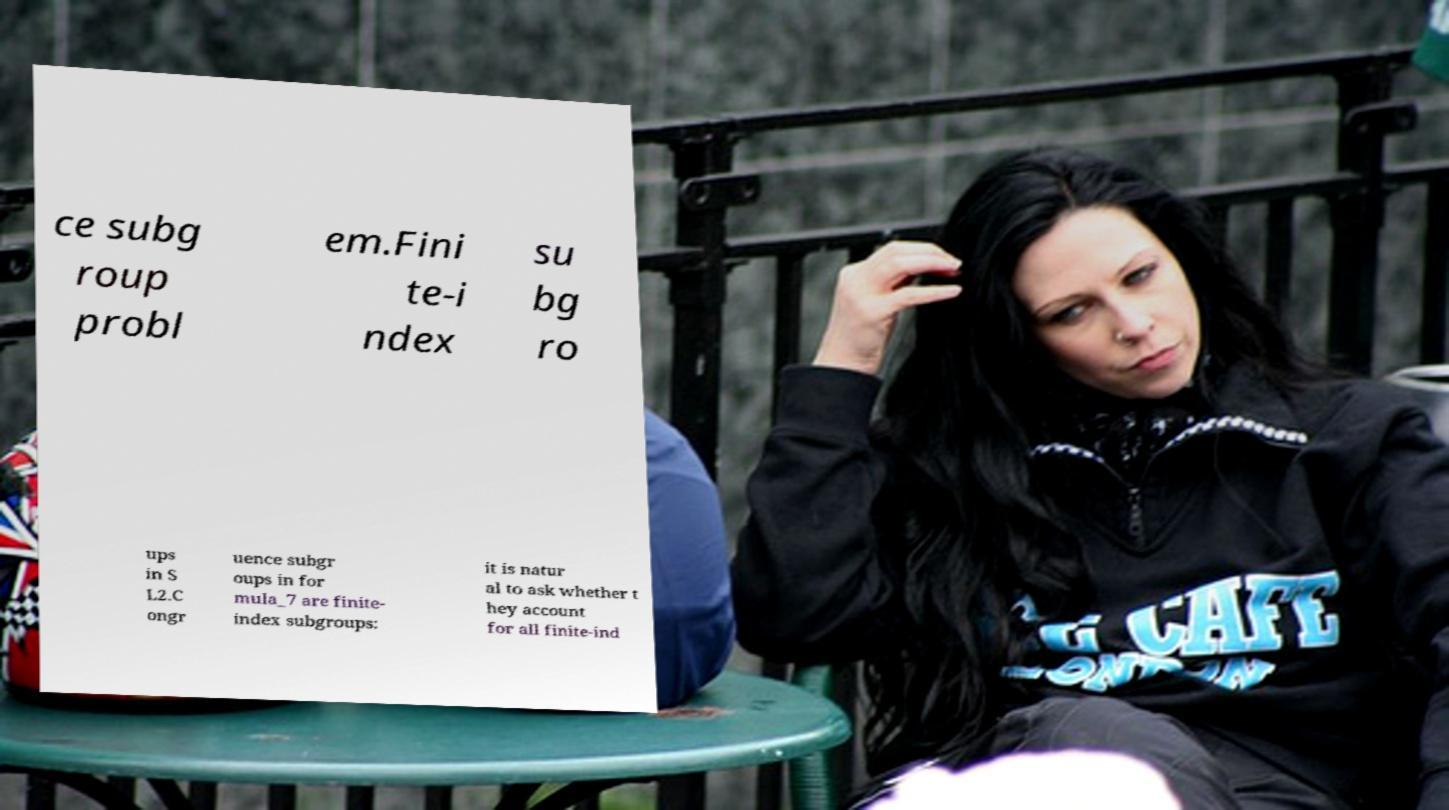Could you extract and type out the text from this image? ce subg roup probl em.Fini te-i ndex su bg ro ups in S L2.C ongr uence subgr oups in for mula_7 are finite- index subgroups: it is natur al to ask whether t hey account for all finite-ind 